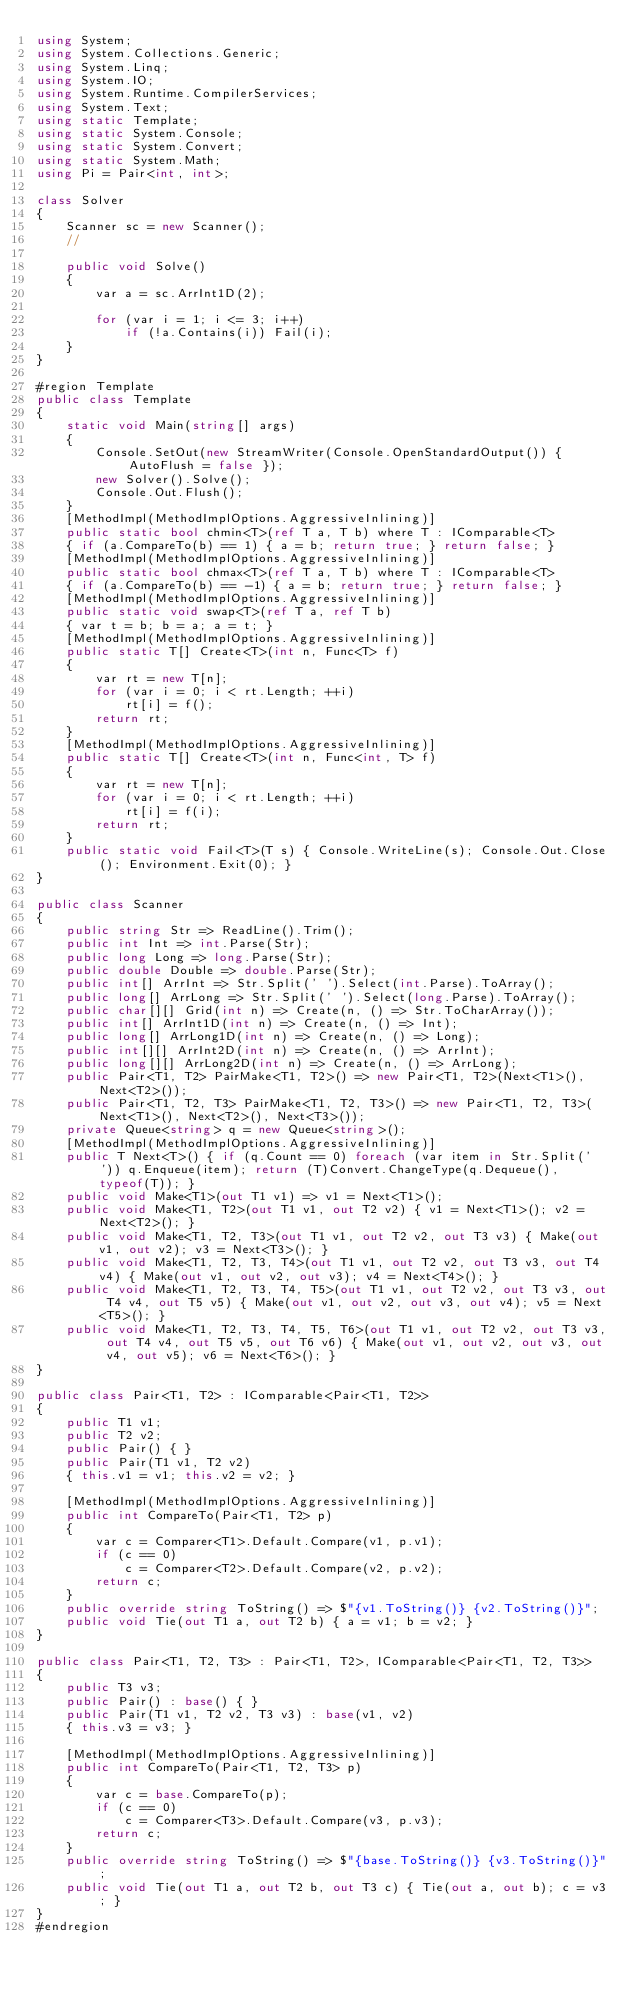<code> <loc_0><loc_0><loc_500><loc_500><_C#_>using System;
using System.Collections.Generic;
using System.Linq;
using System.IO;
using System.Runtime.CompilerServices;
using System.Text;
using static Template;
using static System.Console;
using static System.Convert;
using static System.Math;
using Pi = Pair<int, int>;

class Solver
{
    Scanner sc = new Scanner();
    //

    public void Solve()
    {
        var a = sc.ArrInt1D(2);

        for (var i = 1; i <= 3; i++)
            if (!a.Contains(i)) Fail(i);
    }
}

#region Template
public class Template
{
    static void Main(string[] args)
    {
        Console.SetOut(new StreamWriter(Console.OpenStandardOutput()) { AutoFlush = false });
        new Solver().Solve();
        Console.Out.Flush();
    }
    [MethodImpl(MethodImplOptions.AggressiveInlining)]
    public static bool chmin<T>(ref T a, T b) where T : IComparable<T>
    { if (a.CompareTo(b) == 1) { a = b; return true; } return false; }
    [MethodImpl(MethodImplOptions.AggressiveInlining)]
    public static bool chmax<T>(ref T a, T b) where T : IComparable<T>
    { if (a.CompareTo(b) == -1) { a = b; return true; } return false; }
    [MethodImpl(MethodImplOptions.AggressiveInlining)]
    public static void swap<T>(ref T a, ref T b)
    { var t = b; b = a; a = t; }
    [MethodImpl(MethodImplOptions.AggressiveInlining)]
    public static T[] Create<T>(int n, Func<T> f)
    {
        var rt = new T[n];
        for (var i = 0; i < rt.Length; ++i)
            rt[i] = f();
        return rt;
    }
    [MethodImpl(MethodImplOptions.AggressiveInlining)]
    public static T[] Create<T>(int n, Func<int, T> f)
    {
        var rt = new T[n];
        for (var i = 0; i < rt.Length; ++i)
            rt[i] = f(i);
        return rt;
    }
    public static void Fail<T>(T s) { Console.WriteLine(s); Console.Out.Close(); Environment.Exit(0); }
}

public class Scanner
{
    public string Str => ReadLine().Trim();
    public int Int => int.Parse(Str);
    public long Long => long.Parse(Str);
    public double Double => double.Parse(Str);
    public int[] ArrInt => Str.Split(' ').Select(int.Parse).ToArray();
    public long[] ArrLong => Str.Split(' ').Select(long.Parse).ToArray();
    public char[][] Grid(int n) => Create(n, () => Str.ToCharArray());
    public int[] ArrInt1D(int n) => Create(n, () => Int);
    public long[] ArrLong1D(int n) => Create(n, () => Long);
    public int[][] ArrInt2D(int n) => Create(n, () => ArrInt);
    public long[][] ArrLong2D(int n) => Create(n, () => ArrLong);
    public Pair<T1, T2> PairMake<T1, T2>() => new Pair<T1, T2>(Next<T1>(), Next<T2>());
    public Pair<T1, T2, T3> PairMake<T1, T2, T3>() => new Pair<T1, T2, T3>(Next<T1>(), Next<T2>(), Next<T3>());
    private Queue<string> q = new Queue<string>();
    [MethodImpl(MethodImplOptions.AggressiveInlining)]
    public T Next<T>() { if (q.Count == 0) foreach (var item in Str.Split(' ')) q.Enqueue(item); return (T)Convert.ChangeType(q.Dequeue(), typeof(T)); }
    public void Make<T1>(out T1 v1) => v1 = Next<T1>();
    public void Make<T1, T2>(out T1 v1, out T2 v2) { v1 = Next<T1>(); v2 = Next<T2>(); }
    public void Make<T1, T2, T3>(out T1 v1, out T2 v2, out T3 v3) { Make(out v1, out v2); v3 = Next<T3>(); }
    public void Make<T1, T2, T3, T4>(out T1 v1, out T2 v2, out T3 v3, out T4 v4) { Make(out v1, out v2, out v3); v4 = Next<T4>(); }
    public void Make<T1, T2, T3, T4, T5>(out T1 v1, out T2 v2, out T3 v3, out T4 v4, out T5 v5) { Make(out v1, out v2, out v3, out v4); v5 = Next<T5>(); }
    public void Make<T1, T2, T3, T4, T5, T6>(out T1 v1, out T2 v2, out T3 v3, out T4 v4, out T5 v5, out T6 v6) { Make(out v1, out v2, out v3, out v4, out v5); v6 = Next<T6>(); }
}

public class Pair<T1, T2> : IComparable<Pair<T1, T2>>
{
    public T1 v1;
    public T2 v2;
    public Pair() { }
    public Pair(T1 v1, T2 v2)
    { this.v1 = v1; this.v2 = v2; }

    [MethodImpl(MethodImplOptions.AggressiveInlining)]
    public int CompareTo(Pair<T1, T2> p)
    {
        var c = Comparer<T1>.Default.Compare(v1, p.v1);
        if (c == 0)
            c = Comparer<T2>.Default.Compare(v2, p.v2);
        return c;
    }
    public override string ToString() => $"{v1.ToString()} {v2.ToString()}";
    public void Tie(out T1 a, out T2 b) { a = v1; b = v2; }
}

public class Pair<T1, T2, T3> : Pair<T1, T2>, IComparable<Pair<T1, T2, T3>>
{
    public T3 v3;
    public Pair() : base() { }
    public Pair(T1 v1, T2 v2, T3 v3) : base(v1, v2)
    { this.v3 = v3; }

    [MethodImpl(MethodImplOptions.AggressiveInlining)]
    public int CompareTo(Pair<T1, T2, T3> p)
    {
        var c = base.CompareTo(p);
        if (c == 0)
            c = Comparer<T3>.Default.Compare(v3, p.v3);
        return c;
    }
    public override string ToString() => $"{base.ToString()} {v3.ToString()}";
    public void Tie(out T1 a, out T2 b, out T3 c) { Tie(out a, out b); c = v3; }
}
#endregion
</code> 